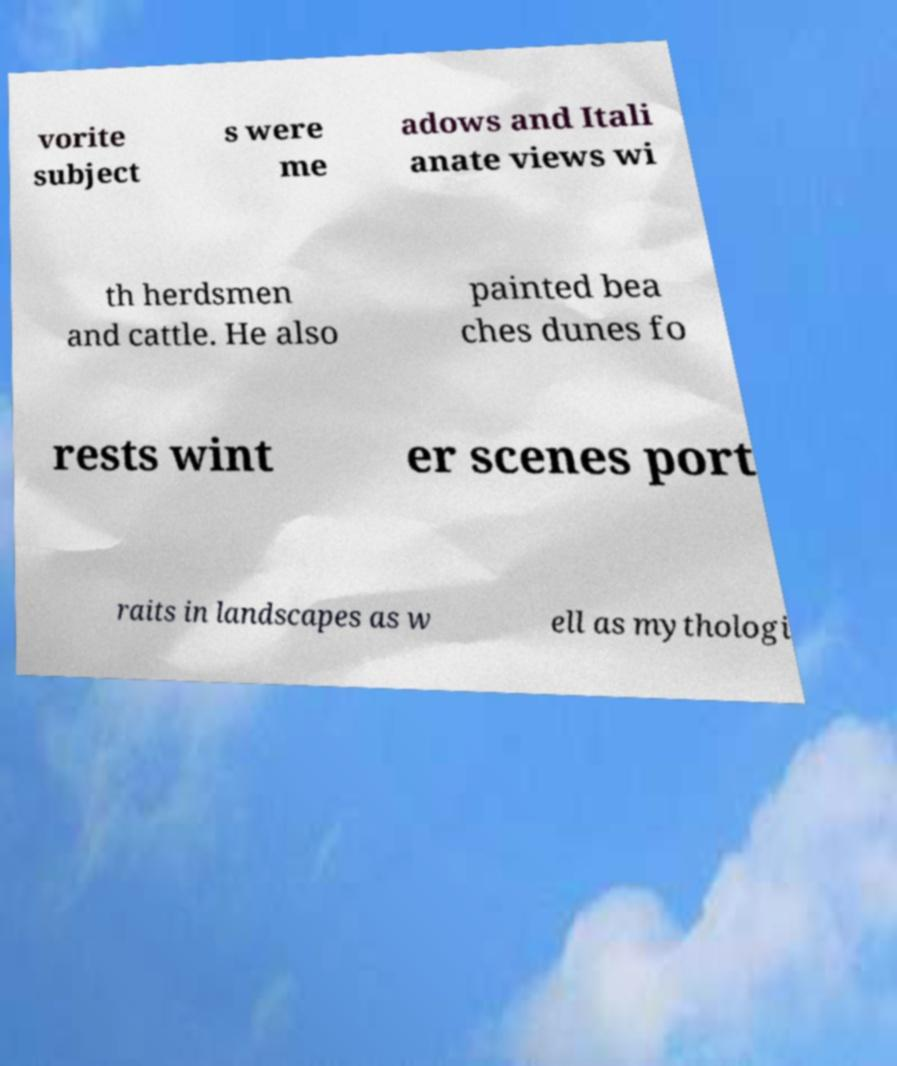Can you accurately transcribe the text from the provided image for me? vorite subject s were me adows and Itali anate views wi th herdsmen and cattle. He also painted bea ches dunes fo rests wint er scenes port raits in landscapes as w ell as mythologi 